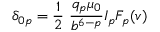<formula> <loc_0><loc_0><loc_500><loc_500>\delta _ { 0 p } = { \frac { 1 } { 2 } } { \frac { q _ { p } \mu _ { 0 } } { b ^ { 6 - p } } } I _ { p } F _ { p } ( v )</formula> 